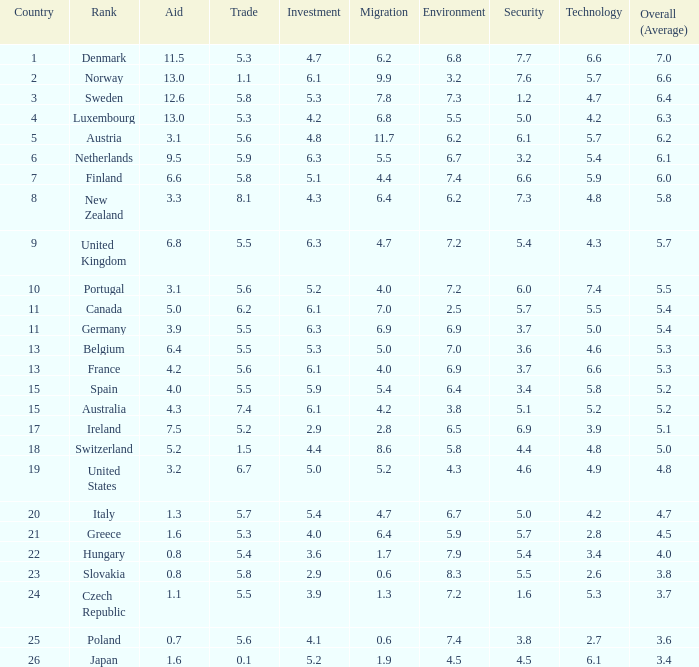What is the migration rating when trade is 5.7? 4.7. 